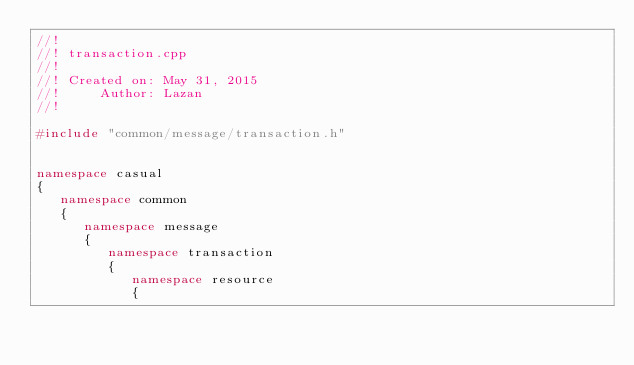Convert code to text. <code><loc_0><loc_0><loc_500><loc_500><_C++_>//!
//! transaction.cpp
//!
//! Created on: May 31, 2015
//!     Author: Lazan
//!

#include "common/message/transaction.h"


namespace casual
{
   namespace common
   {
      namespace message
      {
         namespace transaction
         {
            namespace resource
            {
</code> 